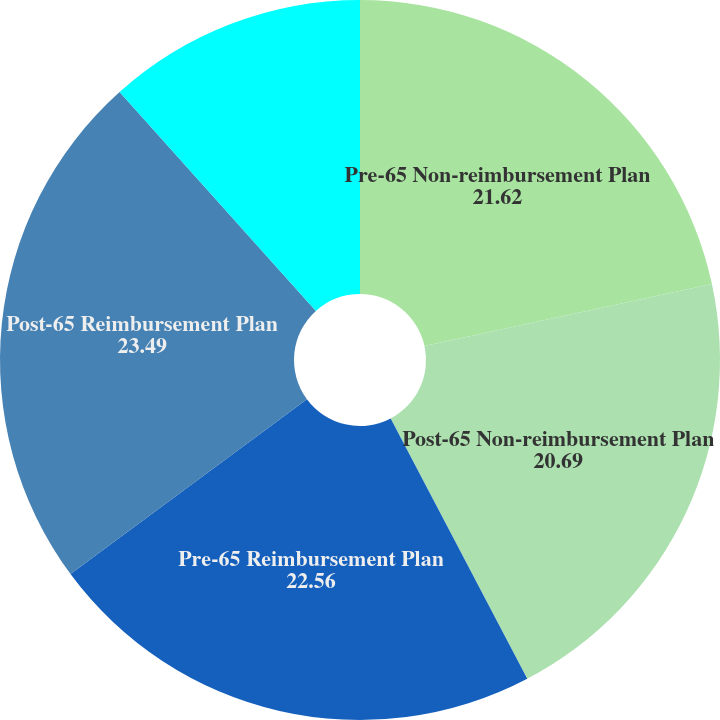Convert chart. <chart><loc_0><loc_0><loc_500><loc_500><pie_chart><fcel>Pre-65 Non-reimbursement Plan<fcel>Post-65 Non-reimbursement Plan<fcel>Pre-65 Reimbursement Plan<fcel>Post-65 Reimbursement Plan<fcel>Rate to which the cost trend<nl><fcel>21.62%<fcel>20.69%<fcel>22.56%<fcel>23.49%<fcel>11.64%<nl></chart> 